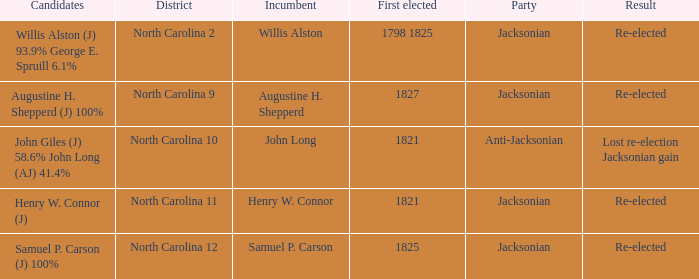Name the total number of party for willis alston 1.0. 